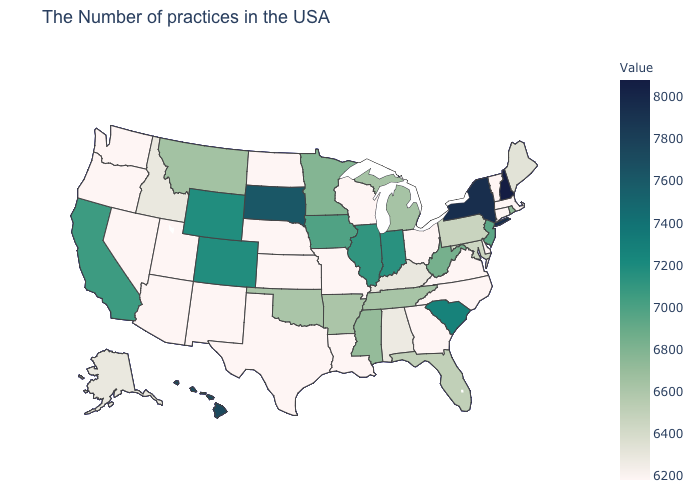Does Hawaii have the highest value in the West?
Short answer required. Yes. Which states have the lowest value in the USA?
Answer briefly. Massachusetts, Vermont, Connecticut, Delaware, Virginia, North Carolina, Ohio, Georgia, Wisconsin, Louisiana, Missouri, Kansas, Nebraska, Texas, North Dakota, New Mexico, Utah, Arizona, Nevada, Washington, Oregon. Which states have the lowest value in the MidWest?
Concise answer only. Ohio, Wisconsin, Missouri, Kansas, Nebraska, North Dakota. Does Nebraska have the lowest value in the USA?
Be succinct. Yes. Which states have the lowest value in the USA?
Give a very brief answer. Massachusetts, Vermont, Connecticut, Delaware, Virginia, North Carolina, Ohio, Georgia, Wisconsin, Louisiana, Missouri, Kansas, Nebraska, Texas, North Dakota, New Mexico, Utah, Arizona, Nevada, Washington, Oregon. Among the states that border North Dakota , which have the highest value?
Be succinct. South Dakota. Among the states that border New York , does New Jersey have the highest value?
Quick response, please. Yes. 